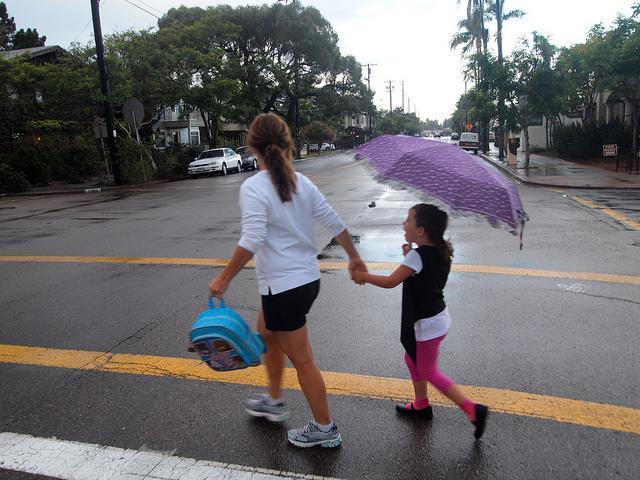How many children are in the walkway?
Give a very brief answer. 1. How many colors are on the umbrella?
Give a very brief answer. 2. How many people can you see?
Give a very brief answer. 2. 